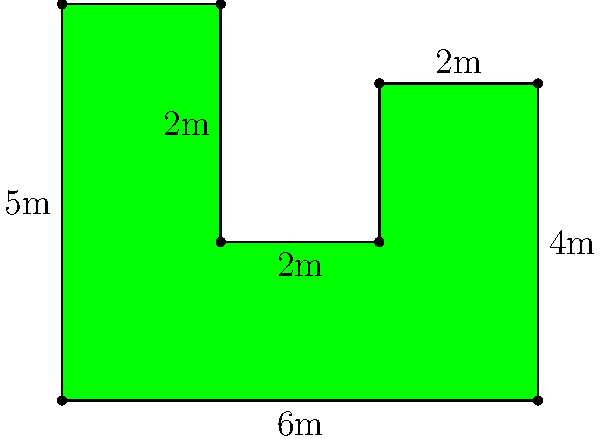As a stand-up comedian, you're asked to perform at a new comedy club. The owner, who claims to be Daniel Tosh's cousin, shows you the oddly-shaped green room. He says it's designed to "inspire creativity" but you suspect it's just a cost-cutting measure. Given the dimensions in the figure, what's the total area of this quirky green room? Let's break this down step-by-step:

1) The room can be divided into three rectangles and one triangle.

2) Rectangle 1 (bottom): 
   $6\text{m} \times 2\text{m} = 12\text{m}^2$

3) Rectangle 2 (middle right): 
   $2\text{m} \times 2\text{m} = 4\text{m}^2$

4) Rectangle 3 (top left): 
   $2\text{m} \times 3\text{m} = 6\text{m}^2$

5) Triangle (top right):
   Base = $2\text{m}$, Height = $2\text{m}$
   Area = $\frac{1}{2} \times 2\text{m} \times 2\text{m} = 2\text{m}^2$

6) Total area:
   $12\text{m}^2 + 4\text{m}^2 + 6\text{m}^2 + 2\text{m}^2 = 24\text{m}^2$

Therefore, the total area of the green room is $24\text{m}^2$.
Answer: $24\text{m}^2$ 